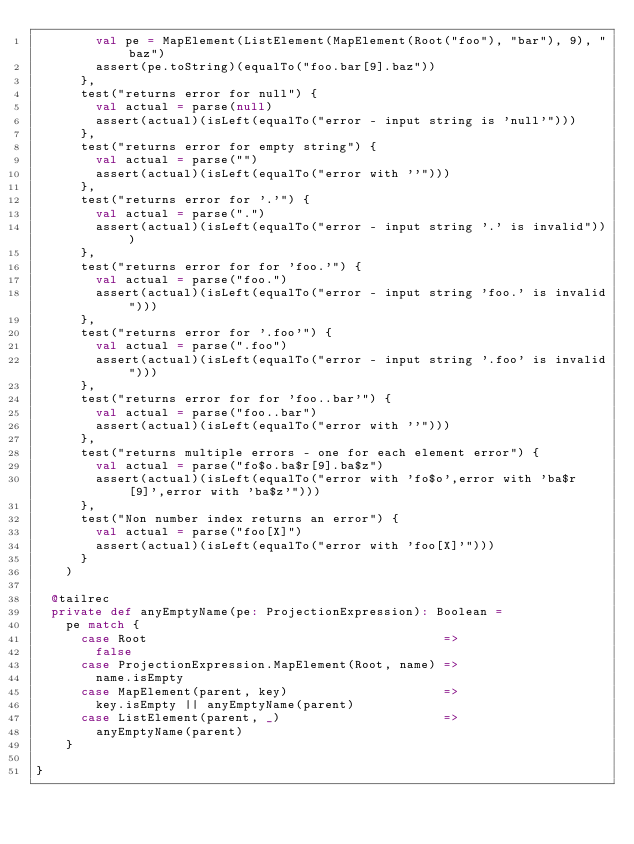<code> <loc_0><loc_0><loc_500><loc_500><_Scala_>        val pe = MapElement(ListElement(MapElement(Root("foo"), "bar"), 9), "baz")
        assert(pe.toString)(equalTo("foo.bar[9].baz"))
      },
      test("returns error for null") {
        val actual = parse(null)
        assert(actual)(isLeft(equalTo("error - input string is 'null'")))
      },
      test("returns error for empty string") {
        val actual = parse("")
        assert(actual)(isLeft(equalTo("error with ''")))
      },
      test("returns error for '.'") {
        val actual = parse(".")
        assert(actual)(isLeft(equalTo("error - input string '.' is invalid")))
      },
      test("returns error for for 'foo.'") {
        val actual = parse("foo.")
        assert(actual)(isLeft(equalTo("error - input string 'foo.' is invalid")))
      },
      test("returns error for '.foo'") {
        val actual = parse(".foo")
        assert(actual)(isLeft(equalTo("error - input string '.foo' is invalid")))
      },
      test("returns error for for 'foo..bar'") {
        val actual = parse("foo..bar")
        assert(actual)(isLeft(equalTo("error with ''")))
      },
      test("returns multiple errors - one for each element error") {
        val actual = parse("fo$o.ba$r[9].ba$z")
        assert(actual)(isLeft(equalTo("error with 'fo$o',error with 'ba$r[9]',error with 'ba$z'")))
      },
      test("Non number index returns an error") {
        val actual = parse("foo[X]")
        assert(actual)(isLeft(equalTo("error with 'foo[X]'")))
      }
    )

  @tailrec
  private def anyEmptyName(pe: ProjectionExpression): Boolean =
    pe match {
      case Root                                        =>
        false
      case ProjectionExpression.MapElement(Root, name) =>
        name.isEmpty
      case MapElement(parent, key)                     =>
        key.isEmpty || anyEmptyName(parent)
      case ListElement(parent, _)                      =>
        anyEmptyName(parent)
    }

}
</code> 